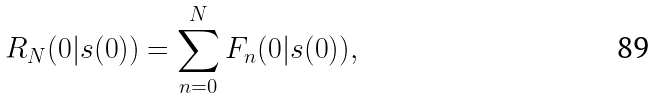Convert formula to latex. <formula><loc_0><loc_0><loc_500><loc_500>R _ { N } ( 0 | s ( 0 ) ) = \sum _ { n = 0 } ^ { N } F _ { n } ( 0 | s ( 0 ) ) ,</formula> 